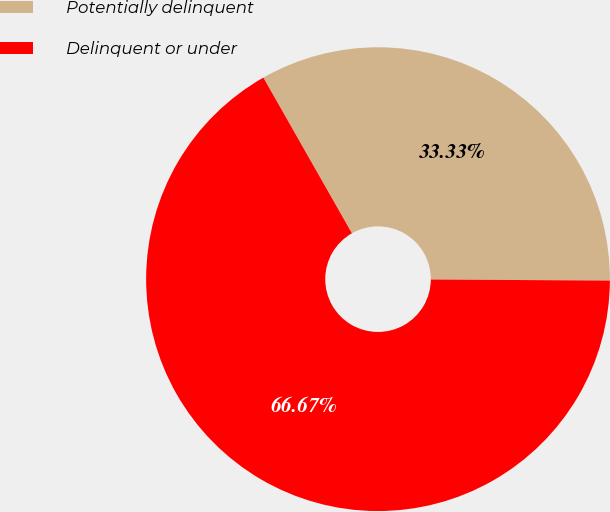Convert chart to OTSL. <chart><loc_0><loc_0><loc_500><loc_500><pie_chart><fcel>Potentially delinquent<fcel>Delinquent or under<nl><fcel>33.33%<fcel>66.67%<nl></chart> 